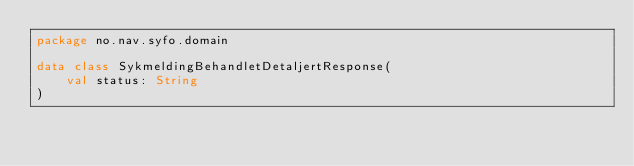Convert code to text. <code><loc_0><loc_0><loc_500><loc_500><_Kotlin_>package no.nav.syfo.domain

data class SykmeldingBehandletDetaljertResponse(
    val status: String
)
</code> 